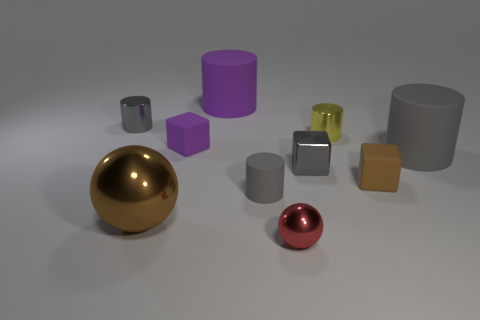How many other objects are there of the same color as the small matte cylinder?
Offer a terse response. 3. What is the color of the matte object that is behind the gray metallic object behind the cylinder that is on the right side of the yellow cylinder?
Your answer should be compact. Purple. Is the number of large brown metal balls in front of the small sphere the same as the number of brown spheres?
Your response must be concise. No. Do the brown object that is on the left side of the yellow object and the tiny purple matte block have the same size?
Your answer should be compact. No. How many small cylinders are there?
Offer a very short reply. 3. How many objects are both in front of the big purple rubber thing and behind the tiny red shiny ball?
Provide a short and direct response. 8. Is there a large brown ball that has the same material as the yellow cylinder?
Offer a very short reply. Yes. There is a small purple thing that is in front of the large object that is behind the yellow shiny cylinder; what is its material?
Provide a short and direct response. Rubber. Are there an equal number of tiny metal things that are in front of the big gray rubber cylinder and gray metal cylinders that are behind the yellow cylinder?
Ensure brevity in your answer.  No. Is the tiny yellow thing the same shape as the tiny brown object?
Your answer should be very brief. No. 